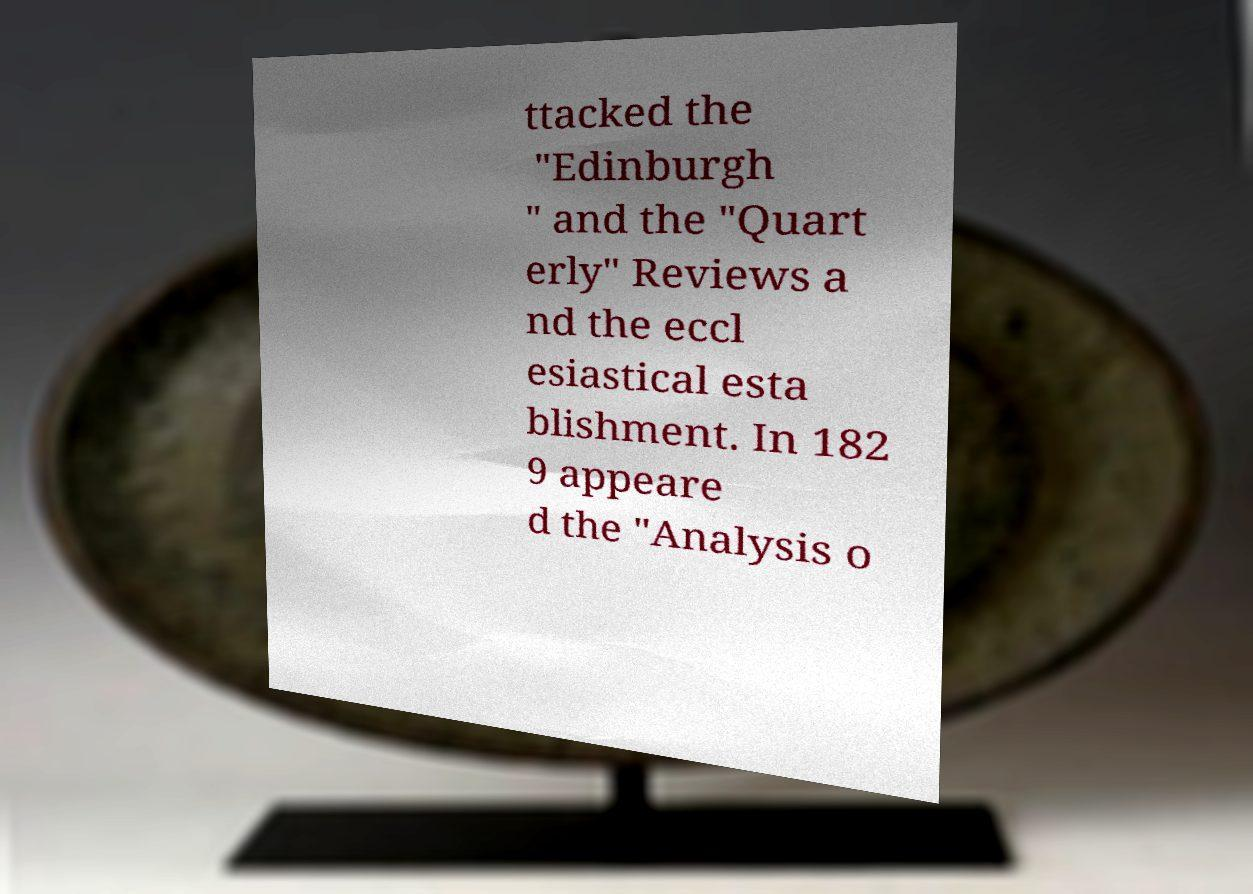I need the written content from this picture converted into text. Can you do that? ttacked the "Edinburgh " and the "Quart erly" Reviews a nd the eccl esiastical esta blishment. In 182 9 appeare d the "Analysis o 